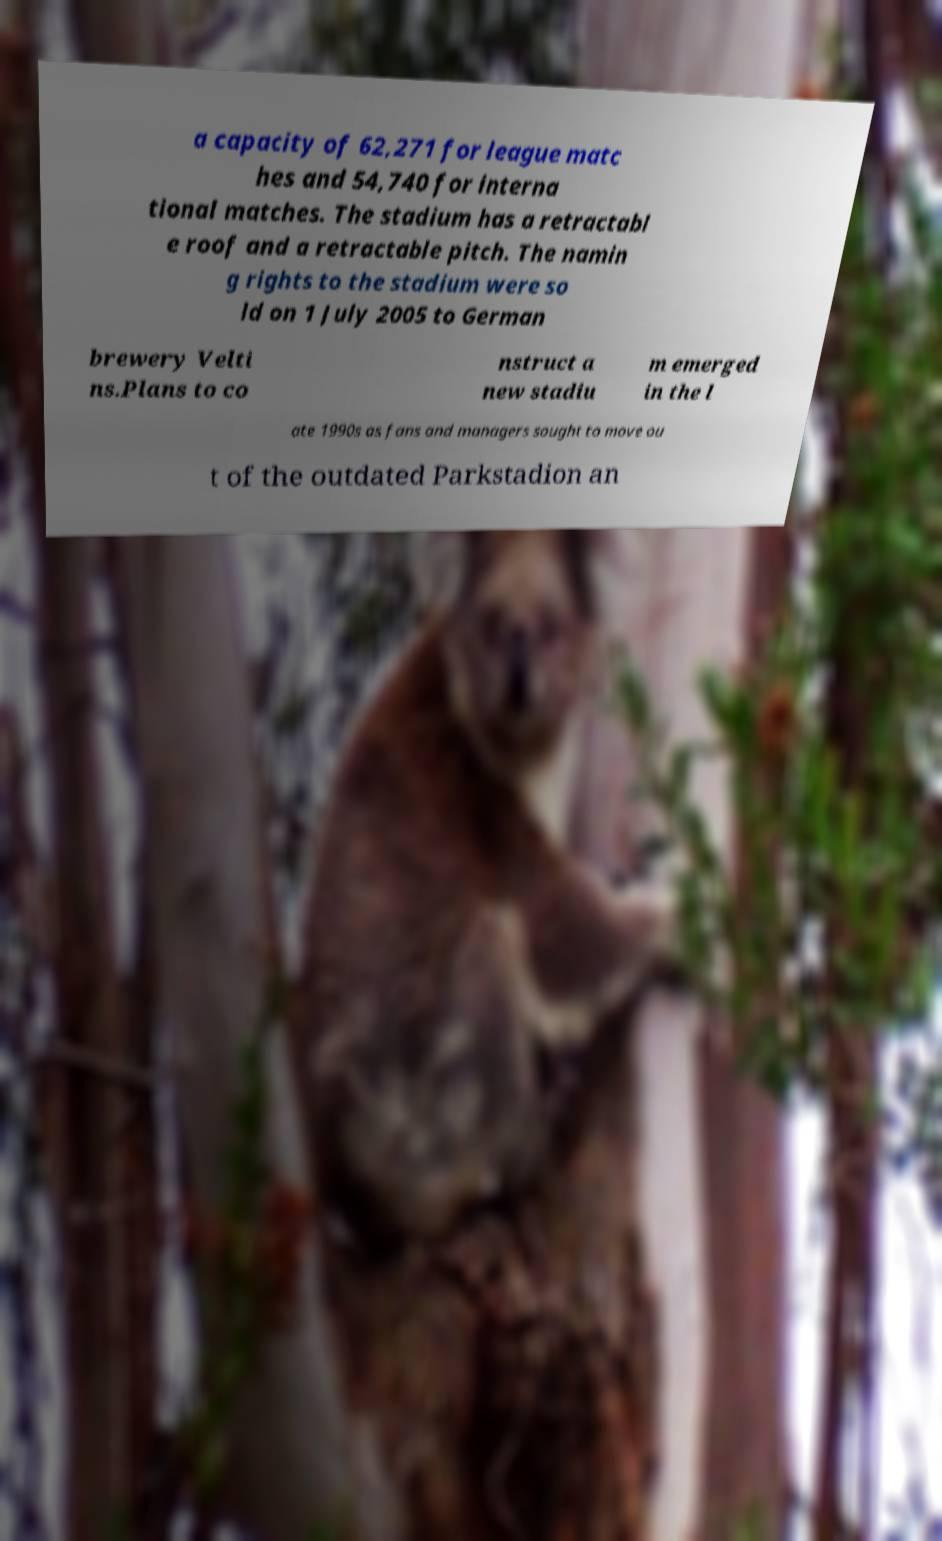Could you extract and type out the text from this image? a capacity of 62,271 for league matc hes and 54,740 for interna tional matches. The stadium has a retractabl e roof and a retractable pitch. The namin g rights to the stadium were so ld on 1 July 2005 to German brewery Velti ns.Plans to co nstruct a new stadiu m emerged in the l ate 1990s as fans and managers sought to move ou t of the outdated Parkstadion an 